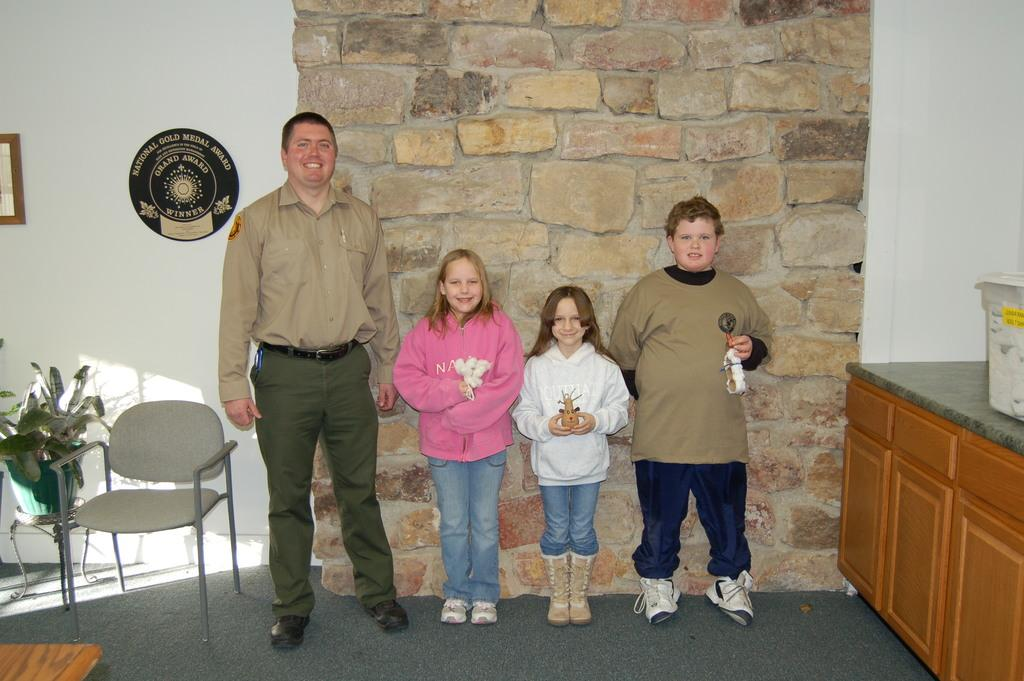How many people are present in the image? There are three people in the image: a man, two girls, and a boy. What is the man doing in the image? The provided facts do not specify what the man is doing in the image. What is the color of the carpet in the image? The carpet in the image is gray. What objects can be seen in the image besides the people? There is a chair and a plant pot in the image. How many ladybugs are crawling on the legs of the chair in the image? There are no ladybugs present in the image, and therefore no such activity can be observed. 